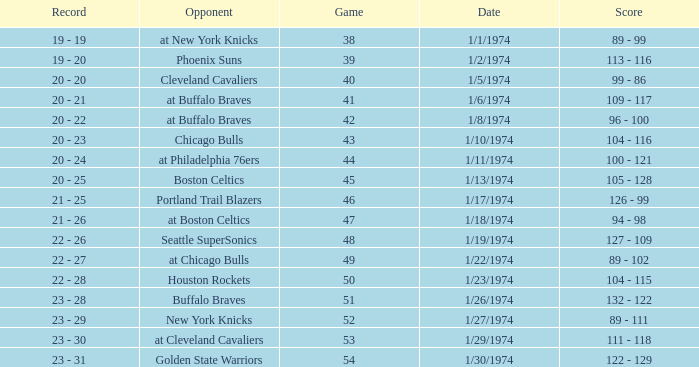What opponent played on 1/13/1974? Boston Celtics. 